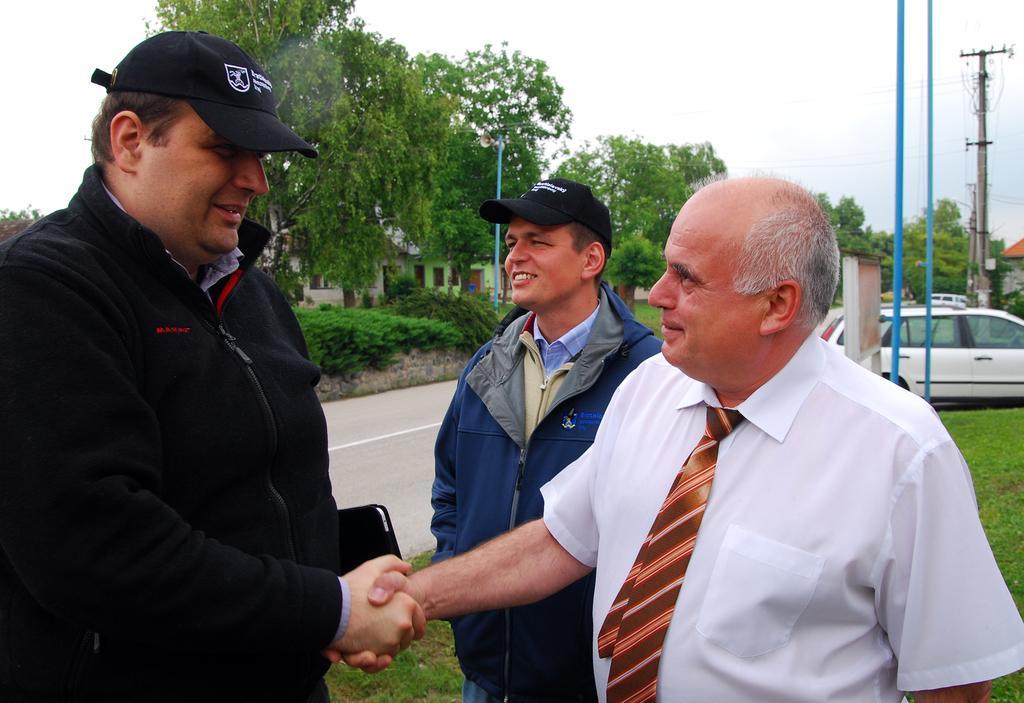How would you summarize this image in a sentence or two? In this picture there is a man who is wearing black jacket and cap. Beside him there is a man who is wearing blue jacket. Beside him there is an old man who is wearing white shirt and tie. They are standing near to the road. On the right I can see many cars which are parked near to the electric poles and electric wires are connected it. In the background I can see the buildings, trees, plants and grass. At the top I can see the sky and clouds. 